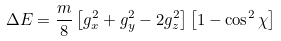<formula> <loc_0><loc_0><loc_500><loc_500>\Delta E = \frac { m } { 8 } \left [ g _ { x } ^ { 2 } + g _ { y } ^ { 2 } - 2 g _ { z } ^ { 2 } \right ] \left [ 1 - \cos ^ { 2 } \chi \right ]</formula> 